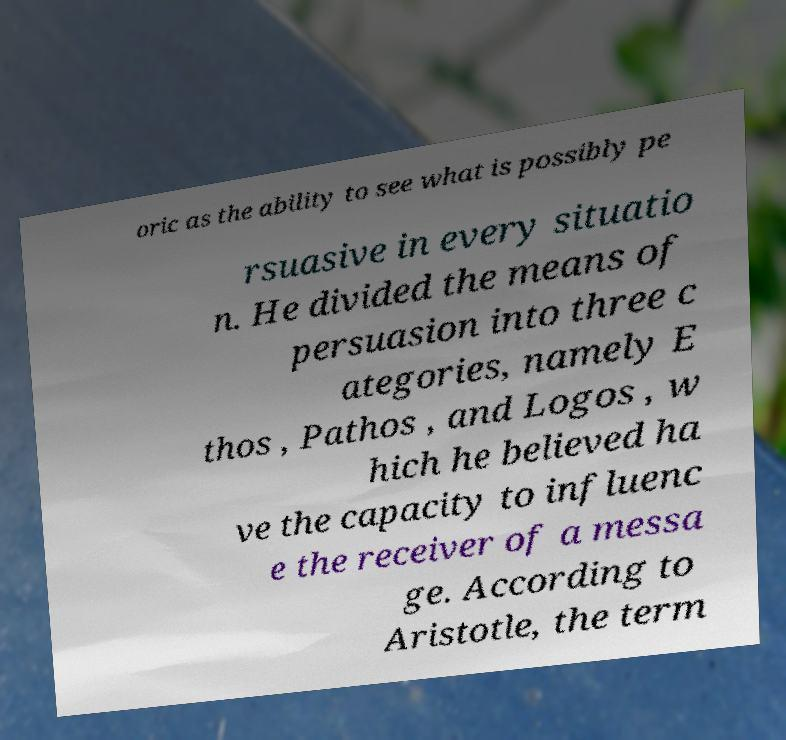Could you extract and type out the text from this image? oric as the ability to see what is possibly pe rsuasive in every situatio n. He divided the means of persuasion into three c ategories, namely E thos , Pathos , and Logos , w hich he believed ha ve the capacity to influenc e the receiver of a messa ge. According to Aristotle, the term 